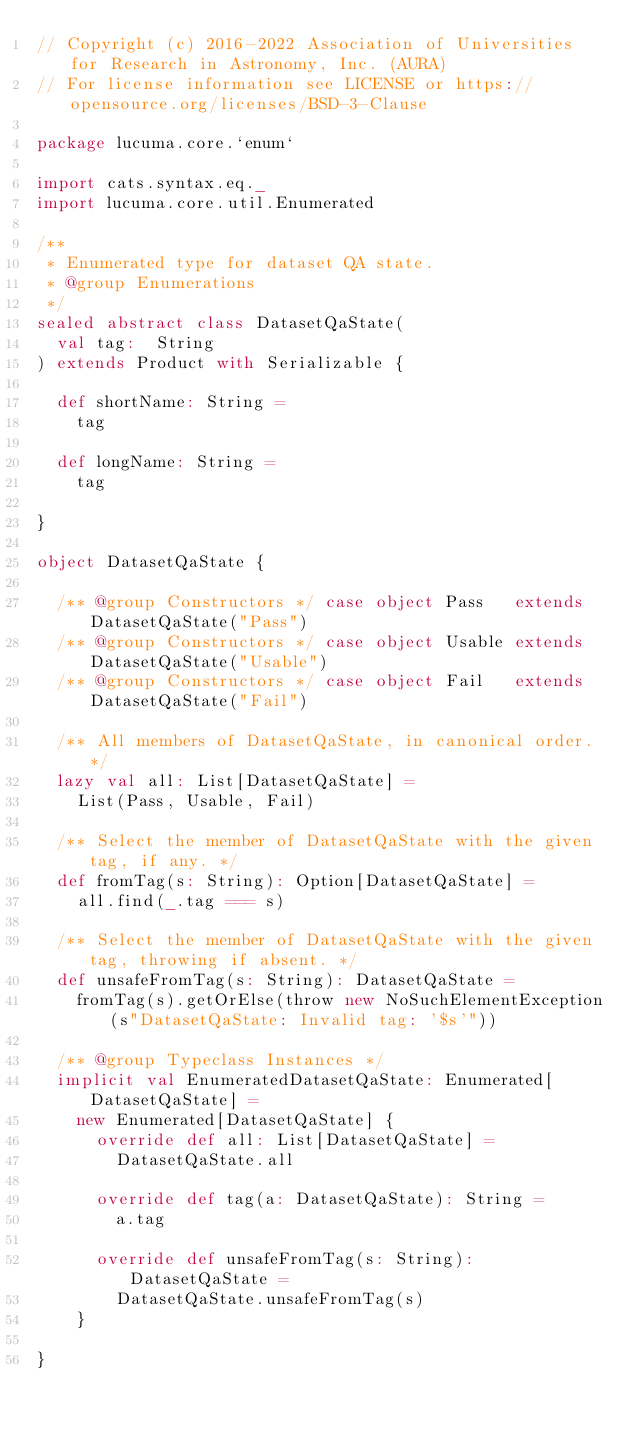Convert code to text. <code><loc_0><loc_0><loc_500><loc_500><_Scala_>// Copyright (c) 2016-2022 Association of Universities for Research in Astronomy, Inc. (AURA)
// For license information see LICENSE or https://opensource.org/licenses/BSD-3-Clause

package lucuma.core.`enum`

import cats.syntax.eq._
import lucuma.core.util.Enumerated

/**
 * Enumerated type for dataset QA state.
 * @group Enumerations
 */
sealed abstract class DatasetQaState(
  val tag:  String
) extends Product with Serializable {

  def shortName: String =
    tag

  def longName: String =
    tag

}

object DatasetQaState {

  /** @group Constructors */ case object Pass   extends DatasetQaState("Pass")
  /** @group Constructors */ case object Usable extends DatasetQaState("Usable")
  /** @group Constructors */ case object Fail   extends DatasetQaState("Fail")

  /** All members of DatasetQaState, in canonical order. */
  lazy val all: List[DatasetQaState] =
    List(Pass, Usable, Fail)

  /** Select the member of DatasetQaState with the given tag, if any. */
  def fromTag(s: String): Option[DatasetQaState] =
    all.find(_.tag === s)

  /** Select the member of DatasetQaState with the given tag, throwing if absent. */
  def unsafeFromTag(s: String): DatasetQaState =
    fromTag(s).getOrElse(throw new NoSuchElementException(s"DatasetQaState: Invalid tag: '$s'"))

  /** @group Typeclass Instances */
  implicit val EnumeratedDatasetQaState: Enumerated[DatasetQaState] =
    new Enumerated[DatasetQaState] {
      override def all: List[DatasetQaState] =
        DatasetQaState.all

      override def tag(a: DatasetQaState): String =
        a.tag

      override def unsafeFromTag(s: String): DatasetQaState =
        DatasetQaState.unsafeFromTag(s)
    }

}
</code> 